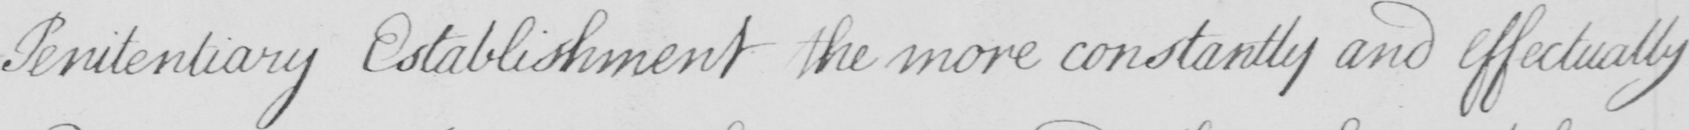What does this handwritten line say? Penitentiary Establishment the more constantly and effectually 